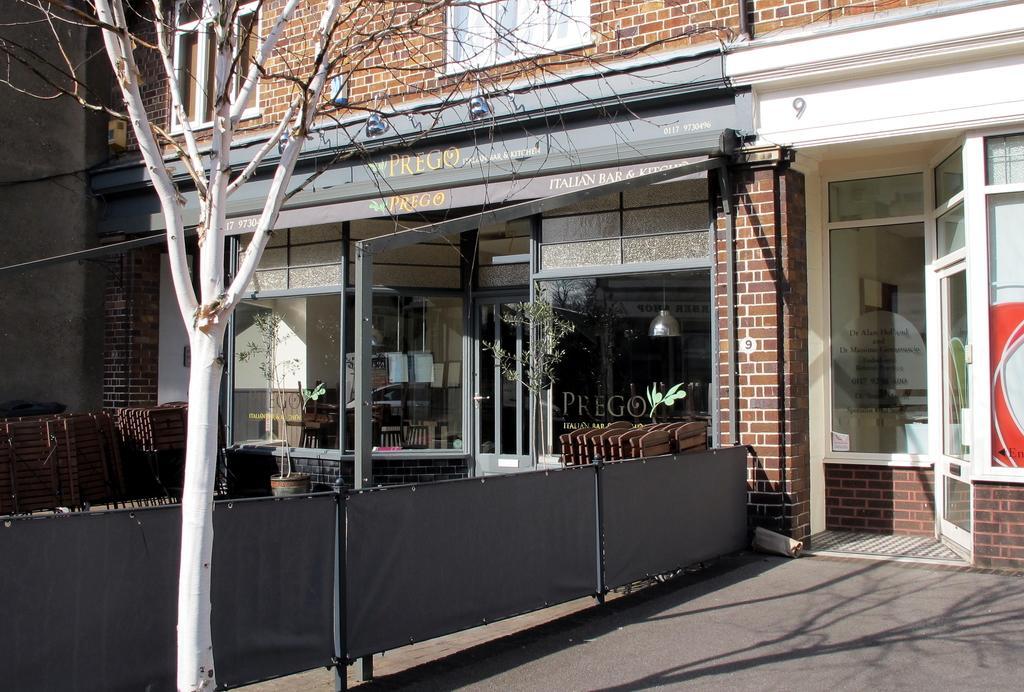How would you summarize this image in a sentence or two? In this image we can see a building with windows. We can also see a barricade, a tree, some boards, a plant in a pot, a ceiling lamp and some text on glass windows. 